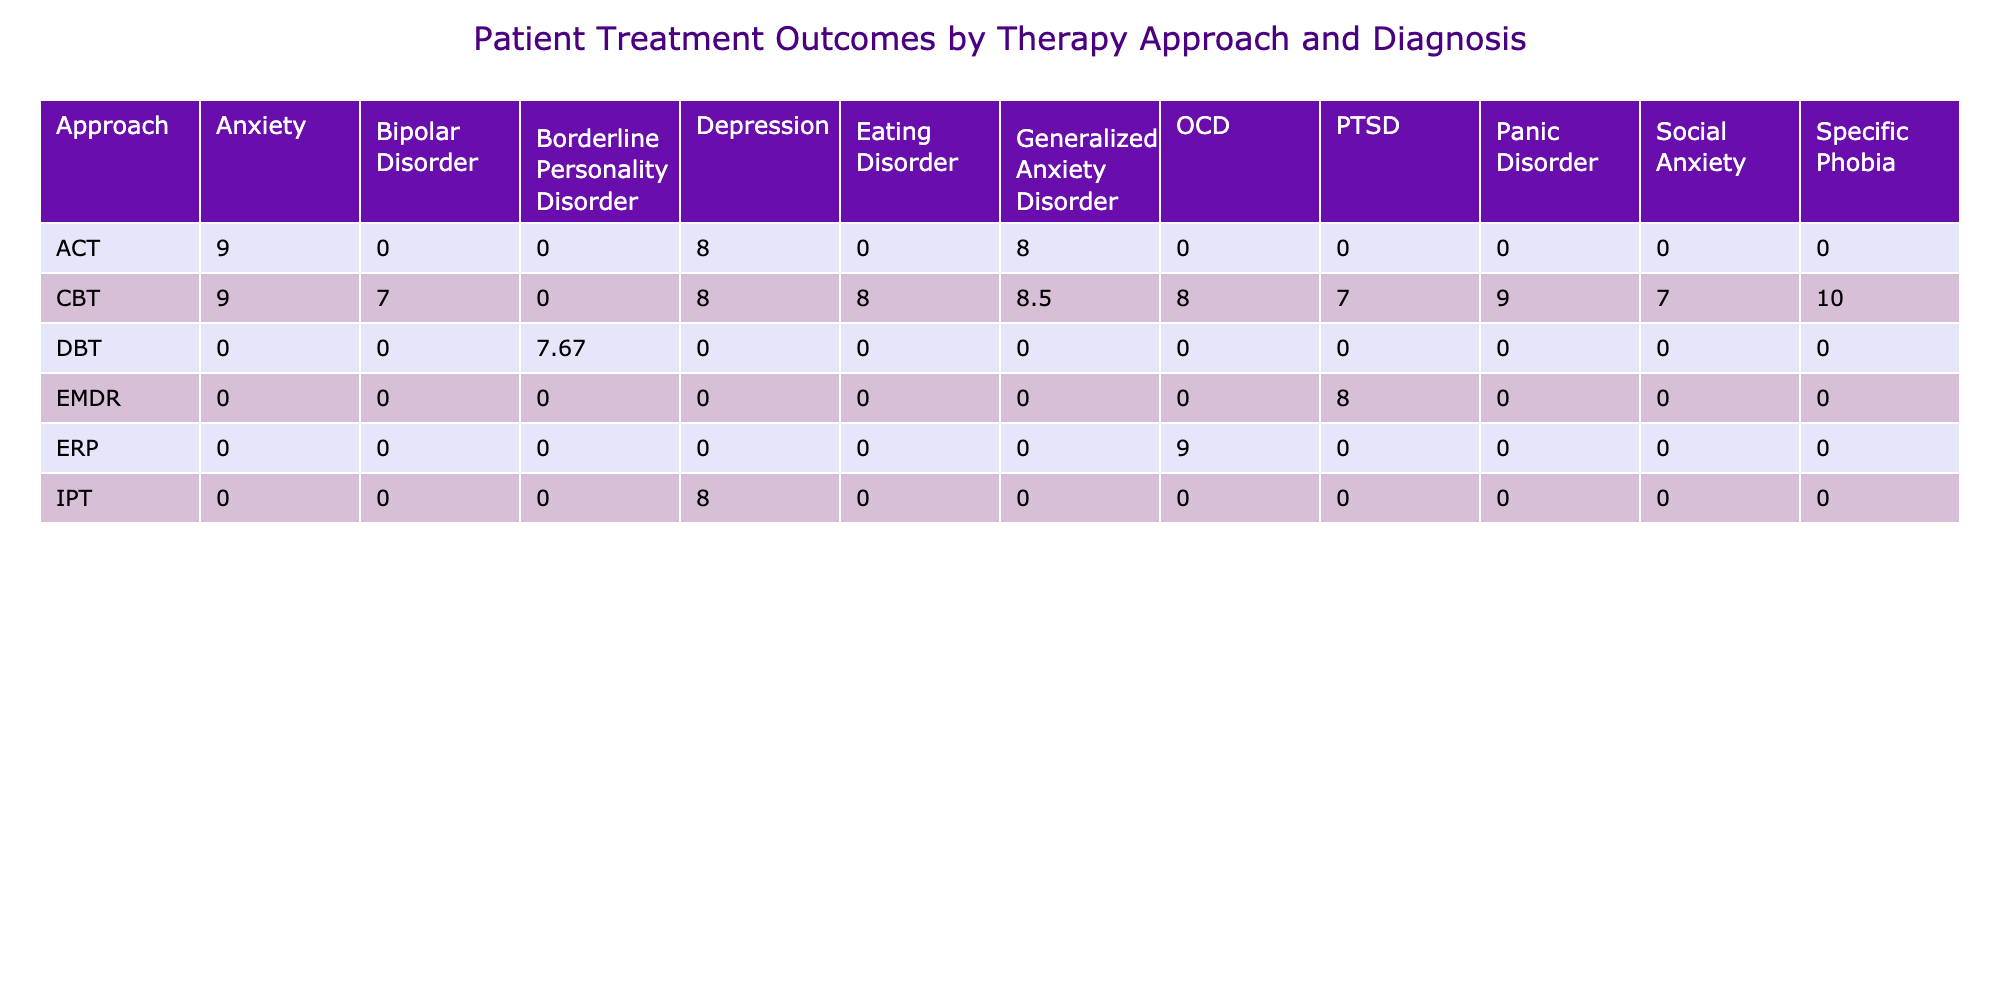What is the average outcome score for CBT in treating Depression? From the table, the outcome scores for CBT with Depression are 8, 7, and 9 from Patient ID P001, P015, and P022. To calculate the average: (8 + 7 + 9) / 3 = 24 / 3 = 8.00.
Answer: 8.00 Which therapy approach has the highest average outcome score for PTSD? The average outcome score for EMDR is 8, and for CBT is 7. The average for DBT is not present since there is only one outcome score of 7. Comparing these, EMDR has the highest average score for PTSD at 8.
Answer: EMDR Is there any patient with the diagnosis of Social Anxiety treated with ACT? The table shows that Dr. Emily Chen treated a patient with Social Anxiety using CBT but no patient is treated with ACT for this diagnosis. Thus, the answer is no.
Answer: No What is the difference in the average outcome score for DBT and CBT in treating Borderline Personality Disorder? The average outcome score for DBT is 7 (based on one entry from Patient ID P023). For CBT, the score is 8 (from Patient ID P004). Thus, the difference is: 8 - 7 = 1.
Answer: 1 Which diagnosis had the lowest average outcome score among the approaches listed? By calculating the averages: Depression (8.00), Anxiety (8.00), PTSD (8.00), OCD (8.67), Specific Phobia (10), Eating Disorder (8), and Borderline Personality Disorder (7). The lowest average outcome score is for Borderline Personality Disorder at 7.
Answer: Borderline Personality Disorder 